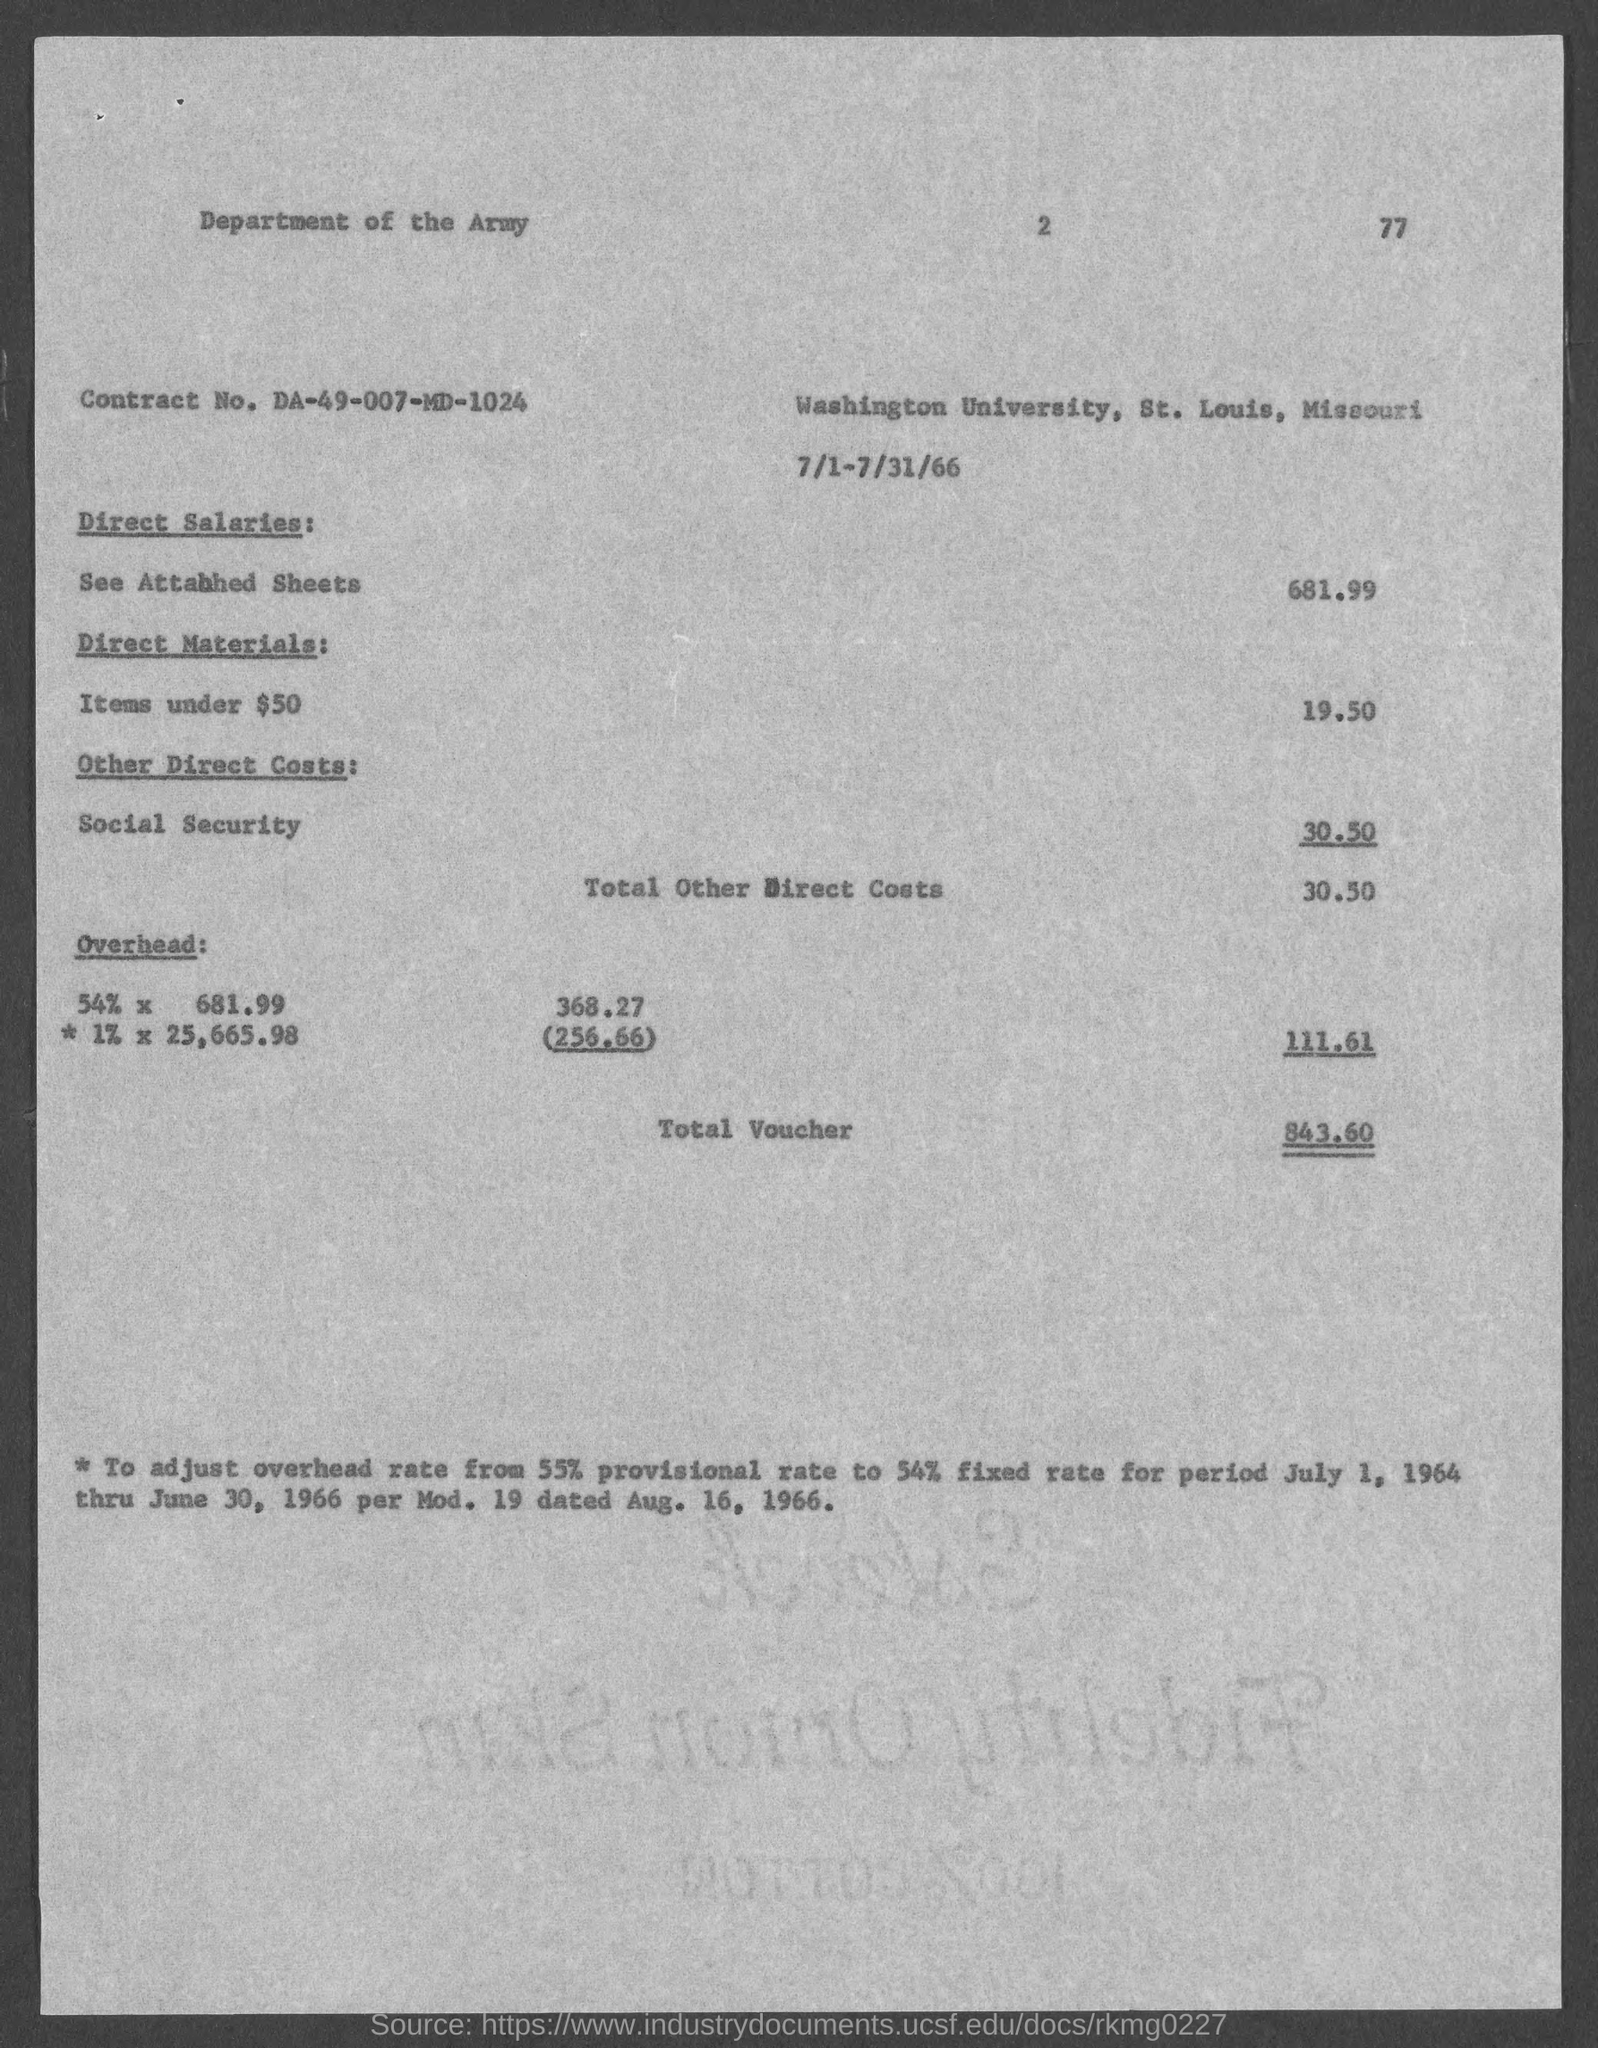Draw attention to some important aspects in this diagram. The contract number is DA-49-007-MD-1024. The total voucher amount is 843.60. 